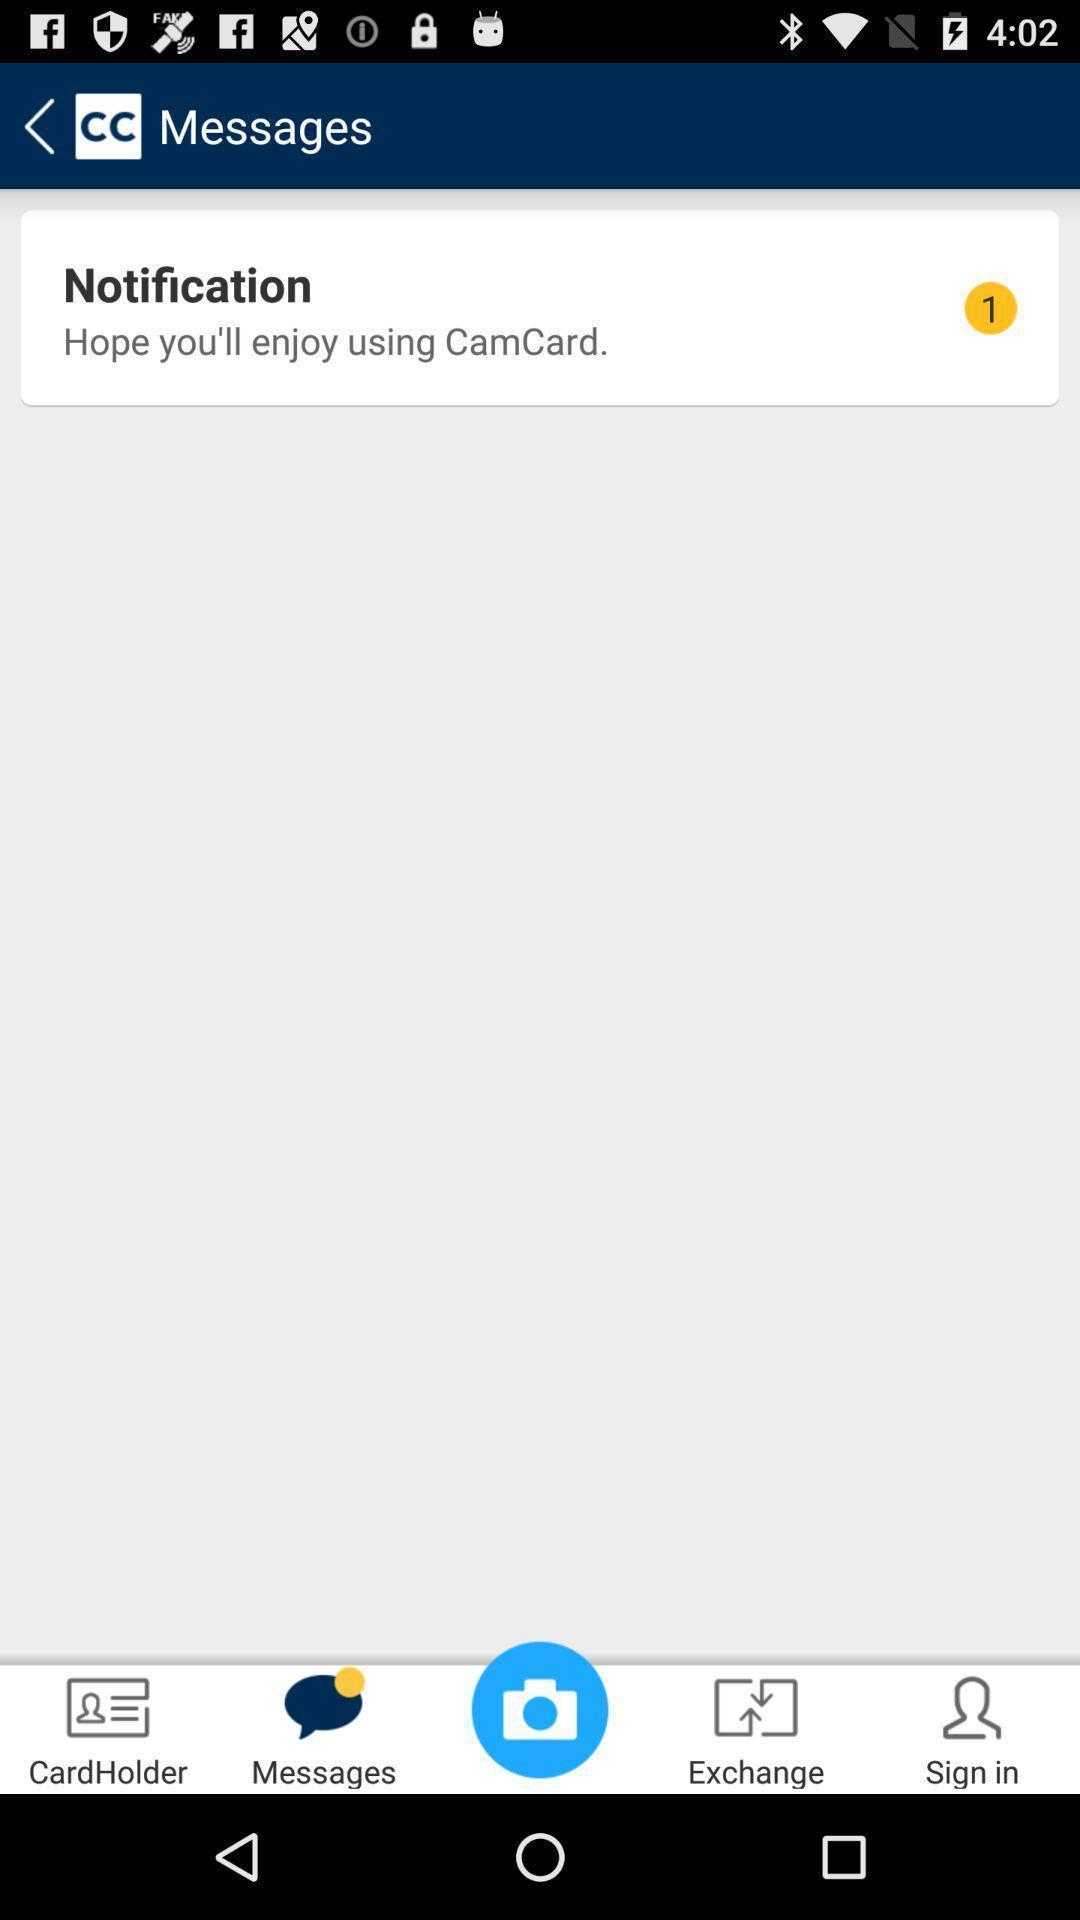Describe this image in words. Screen displaying multiple options in a messaging application. 